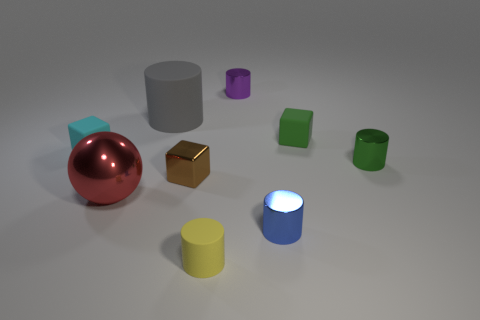There is a tiny rubber cube left of the small block in front of the green metallic object; what number of green objects are in front of it? 1 